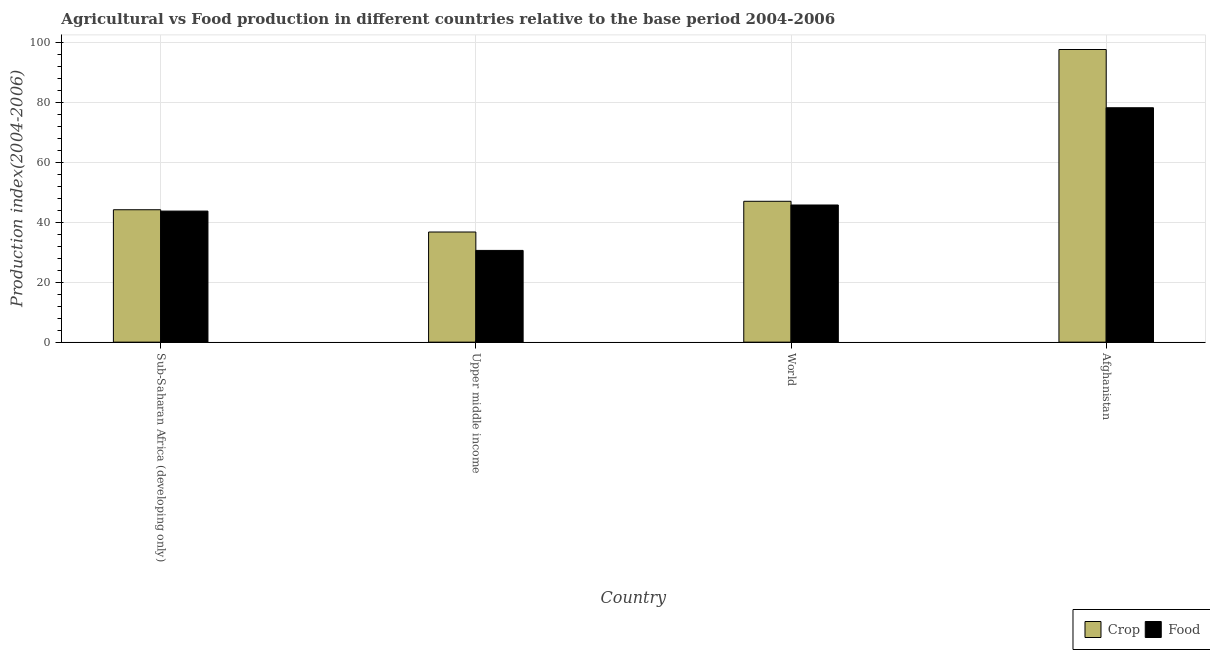How many different coloured bars are there?
Make the answer very short. 2. How many bars are there on the 4th tick from the left?
Offer a very short reply. 2. How many bars are there on the 4th tick from the right?
Make the answer very short. 2. What is the label of the 1st group of bars from the left?
Keep it short and to the point. Sub-Saharan Africa (developing only). What is the food production index in Sub-Saharan Africa (developing only)?
Offer a terse response. 43.75. Across all countries, what is the maximum food production index?
Provide a succinct answer. 78.24. Across all countries, what is the minimum crop production index?
Ensure brevity in your answer.  36.77. In which country was the crop production index maximum?
Make the answer very short. Afghanistan. In which country was the crop production index minimum?
Provide a succinct answer. Upper middle income. What is the total crop production index in the graph?
Offer a very short reply. 225.66. What is the difference between the crop production index in Sub-Saharan Africa (developing only) and that in Upper middle income?
Your answer should be compact. 7.43. What is the difference between the food production index in Upper middle income and the crop production index in World?
Your answer should be compact. -16.4. What is the average food production index per country?
Offer a very short reply. 49.6. What is the difference between the crop production index and food production index in Upper middle income?
Your response must be concise. 6.15. In how many countries, is the crop production index greater than 88 ?
Provide a succinct answer. 1. What is the ratio of the crop production index in Afghanistan to that in World?
Ensure brevity in your answer.  2.08. What is the difference between the highest and the second highest crop production index?
Your response must be concise. 50.66. What is the difference between the highest and the lowest crop production index?
Provide a short and direct response. 60.91. In how many countries, is the crop production index greater than the average crop production index taken over all countries?
Ensure brevity in your answer.  1. Is the sum of the crop production index in Afghanistan and World greater than the maximum food production index across all countries?
Offer a very short reply. Yes. What does the 2nd bar from the left in Sub-Saharan Africa (developing only) represents?
Your response must be concise. Food. What does the 2nd bar from the right in Sub-Saharan Africa (developing only) represents?
Your response must be concise. Crop. How many bars are there?
Provide a succinct answer. 8. Does the graph contain grids?
Provide a succinct answer. Yes. How are the legend labels stacked?
Provide a succinct answer. Horizontal. What is the title of the graph?
Give a very brief answer. Agricultural vs Food production in different countries relative to the base period 2004-2006. What is the label or title of the Y-axis?
Provide a short and direct response. Production index(2004-2006). What is the Production index(2004-2006) of Crop in Sub-Saharan Africa (developing only)?
Provide a succinct answer. 44.19. What is the Production index(2004-2006) in Food in Sub-Saharan Africa (developing only)?
Your answer should be compact. 43.75. What is the Production index(2004-2006) in Crop in Upper middle income?
Your response must be concise. 36.77. What is the Production index(2004-2006) of Food in Upper middle income?
Provide a short and direct response. 30.62. What is the Production index(2004-2006) in Crop in World?
Keep it short and to the point. 47.02. What is the Production index(2004-2006) of Food in World?
Give a very brief answer. 45.78. What is the Production index(2004-2006) of Crop in Afghanistan?
Provide a short and direct response. 97.68. What is the Production index(2004-2006) in Food in Afghanistan?
Keep it short and to the point. 78.24. Across all countries, what is the maximum Production index(2004-2006) in Crop?
Keep it short and to the point. 97.68. Across all countries, what is the maximum Production index(2004-2006) in Food?
Keep it short and to the point. 78.24. Across all countries, what is the minimum Production index(2004-2006) of Crop?
Provide a short and direct response. 36.77. Across all countries, what is the minimum Production index(2004-2006) in Food?
Give a very brief answer. 30.62. What is the total Production index(2004-2006) in Crop in the graph?
Offer a very short reply. 225.66. What is the total Production index(2004-2006) in Food in the graph?
Keep it short and to the point. 198.39. What is the difference between the Production index(2004-2006) of Crop in Sub-Saharan Africa (developing only) and that in Upper middle income?
Ensure brevity in your answer.  7.43. What is the difference between the Production index(2004-2006) in Food in Sub-Saharan Africa (developing only) and that in Upper middle income?
Your answer should be compact. 13.13. What is the difference between the Production index(2004-2006) in Crop in Sub-Saharan Africa (developing only) and that in World?
Give a very brief answer. -2.83. What is the difference between the Production index(2004-2006) of Food in Sub-Saharan Africa (developing only) and that in World?
Provide a short and direct response. -2.03. What is the difference between the Production index(2004-2006) in Crop in Sub-Saharan Africa (developing only) and that in Afghanistan?
Offer a very short reply. -53.49. What is the difference between the Production index(2004-2006) of Food in Sub-Saharan Africa (developing only) and that in Afghanistan?
Make the answer very short. -34.49. What is the difference between the Production index(2004-2006) in Crop in Upper middle income and that in World?
Offer a terse response. -10.25. What is the difference between the Production index(2004-2006) in Food in Upper middle income and that in World?
Provide a short and direct response. -15.16. What is the difference between the Production index(2004-2006) in Crop in Upper middle income and that in Afghanistan?
Offer a terse response. -60.91. What is the difference between the Production index(2004-2006) of Food in Upper middle income and that in Afghanistan?
Your answer should be compact. -47.62. What is the difference between the Production index(2004-2006) of Crop in World and that in Afghanistan?
Offer a very short reply. -50.66. What is the difference between the Production index(2004-2006) in Food in World and that in Afghanistan?
Offer a very short reply. -32.46. What is the difference between the Production index(2004-2006) of Crop in Sub-Saharan Africa (developing only) and the Production index(2004-2006) of Food in Upper middle income?
Provide a succinct answer. 13.57. What is the difference between the Production index(2004-2006) of Crop in Sub-Saharan Africa (developing only) and the Production index(2004-2006) of Food in World?
Your answer should be compact. -1.59. What is the difference between the Production index(2004-2006) of Crop in Sub-Saharan Africa (developing only) and the Production index(2004-2006) of Food in Afghanistan?
Keep it short and to the point. -34.05. What is the difference between the Production index(2004-2006) of Crop in Upper middle income and the Production index(2004-2006) of Food in World?
Your response must be concise. -9.02. What is the difference between the Production index(2004-2006) of Crop in Upper middle income and the Production index(2004-2006) of Food in Afghanistan?
Provide a short and direct response. -41.47. What is the difference between the Production index(2004-2006) of Crop in World and the Production index(2004-2006) of Food in Afghanistan?
Your answer should be compact. -31.22. What is the average Production index(2004-2006) of Crop per country?
Provide a succinct answer. 56.41. What is the average Production index(2004-2006) of Food per country?
Your answer should be very brief. 49.6. What is the difference between the Production index(2004-2006) of Crop and Production index(2004-2006) of Food in Sub-Saharan Africa (developing only)?
Your answer should be very brief. 0.45. What is the difference between the Production index(2004-2006) of Crop and Production index(2004-2006) of Food in Upper middle income?
Offer a terse response. 6.15. What is the difference between the Production index(2004-2006) of Crop and Production index(2004-2006) of Food in World?
Your answer should be very brief. 1.24. What is the difference between the Production index(2004-2006) of Crop and Production index(2004-2006) of Food in Afghanistan?
Provide a short and direct response. 19.44. What is the ratio of the Production index(2004-2006) in Crop in Sub-Saharan Africa (developing only) to that in Upper middle income?
Provide a succinct answer. 1.2. What is the ratio of the Production index(2004-2006) of Food in Sub-Saharan Africa (developing only) to that in Upper middle income?
Ensure brevity in your answer.  1.43. What is the ratio of the Production index(2004-2006) in Crop in Sub-Saharan Africa (developing only) to that in World?
Make the answer very short. 0.94. What is the ratio of the Production index(2004-2006) of Food in Sub-Saharan Africa (developing only) to that in World?
Your response must be concise. 0.96. What is the ratio of the Production index(2004-2006) of Crop in Sub-Saharan Africa (developing only) to that in Afghanistan?
Offer a terse response. 0.45. What is the ratio of the Production index(2004-2006) of Food in Sub-Saharan Africa (developing only) to that in Afghanistan?
Provide a short and direct response. 0.56. What is the ratio of the Production index(2004-2006) in Crop in Upper middle income to that in World?
Provide a succinct answer. 0.78. What is the ratio of the Production index(2004-2006) of Food in Upper middle income to that in World?
Provide a succinct answer. 0.67. What is the ratio of the Production index(2004-2006) in Crop in Upper middle income to that in Afghanistan?
Your answer should be very brief. 0.38. What is the ratio of the Production index(2004-2006) in Food in Upper middle income to that in Afghanistan?
Provide a short and direct response. 0.39. What is the ratio of the Production index(2004-2006) of Crop in World to that in Afghanistan?
Keep it short and to the point. 0.48. What is the ratio of the Production index(2004-2006) of Food in World to that in Afghanistan?
Make the answer very short. 0.59. What is the difference between the highest and the second highest Production index(2004-2006) in Crop?
Make the answer very short. 50.66. What is the difference between the highest and the second highest Production index(2004-2006) of Food?
Provide a succinct answer. 32.46. What is the difference between the highest and the lowest Production index(2004-2006) in Crop?
Provide a succinct answer. 60.91. What is the difference between the highest and the lowest Production index(2004-2006) of Food?
Keep it short and to the point. 47.62. 